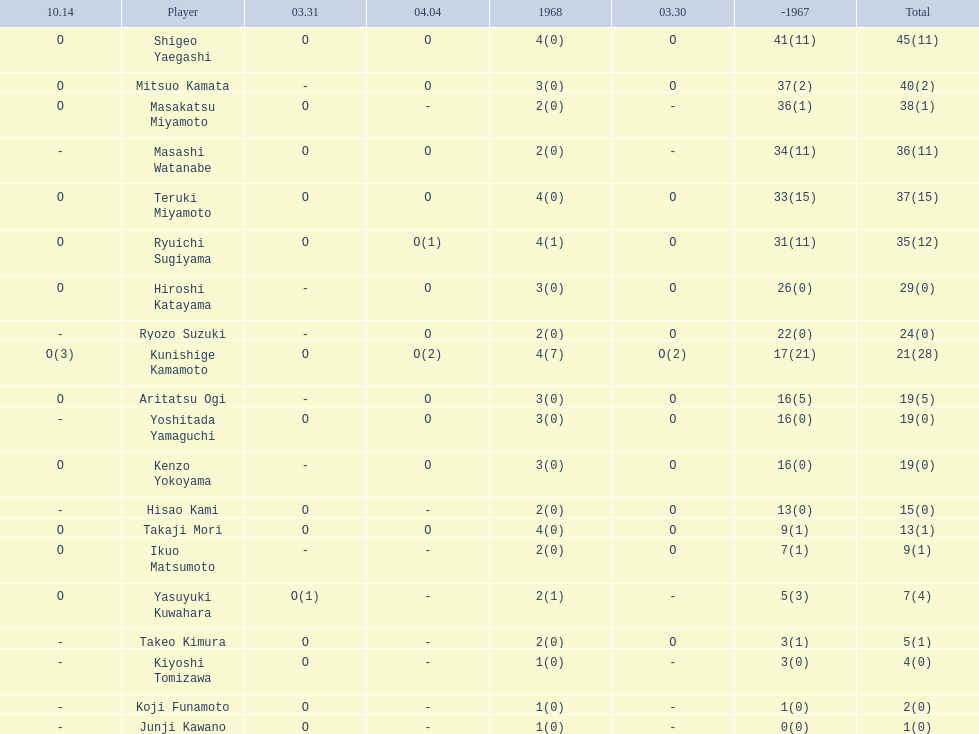How many points did takaji mori have? 13(1). Could you help me parse every detail presented in this table? {'header': ['10.14', 'Player', '03.31', '04.04', '1968', '03.30', '-1967', 'Total'], 'rows': [['O', 'Shigeo Yaegashi', 'O', 'O', '4(0)', 'O', '41(11)', '45(11)'], ['O', 'Mitsuo Kamata', '-', 'O', '3(0)', 'O', '37(2)', '40(2)'], ['O', 'Masakatsu Miyamoto', 'O', '-', '2(0)', '-', '36(1)', '38(1)'], ['-', 'Masashi Watanabe', 'O', 'O', '2(0)', '-', '34(11)', '36(11)'], ['O', 'Teruki Miyamoto', 'O', 'O', '4(0)', 'O', '33(15)', '37(15)'], ['O', 'Ryuichi Sugiyama', 'O', 'O(1)', '4(1)', 'O', '31(11)', '35(12)'], ['O', 'Hiroshi Katayama', '-', 'O', '3(0)', 'O', '26(0)', '29(0)'], ['-', 'Ryozo Suzuki', '-', 'O', '2(0)', 'O', '22(0)', '24(0)'], ['O(3)', 'Kunishige Kamamoto', 'O', 'O(2)', '4(7)', 'O(2)', '17(21)', '21(28)'], ['O', 'Aritatsu Ogi', '-', 'O', '3(0)', 'O', '16(5)', '19(5)'], ['-', 'Yoshitada Yamaguchi', 'O', 'O', '3(0)', 'O', '16(0)', '19(0)'], ['O', 'Kenzo Yokoyama', '-', 'O', '3(0)', 'O', '16(0)', '19(0)'], ['-', 'Hisao Kami', 'O', '-', '2(0)', 'O', '13(0)', '15(0)'], ['O', 'Takaji Mori', 'O', 'O', '4(0)', 'O', '9(1)', '13(1)'], ['O', 'Ikuo Matsumoto', '-', '-', '2(0)', 'O', '7(1)', '9(1)'], ['O', 'Yasuyuki Kuwahara', 'O(1)', '-', '2(1)', '-', '5(3)', '7(4)'], ['-', 'Takeo Kimura', 'O', '-', '2(0)', 'O', '3(1)', '5(1)'], ['-', 'Kiyoshi Tomizawa', 'O', '-', '1(0)', '-', '3(0)', '4(0)'], ['-', 'Koji Funamoto', 'O', '-', '1(0)', '-', '1(0)', '2(0)'], ['-', 'Junji Kawano', 'O', '-', '1(0)', '-', '0(0)', '1(0)']]} And how many points did junji kawano have? 1(0). To who does the higher of these belong to? Takaji Mori. 